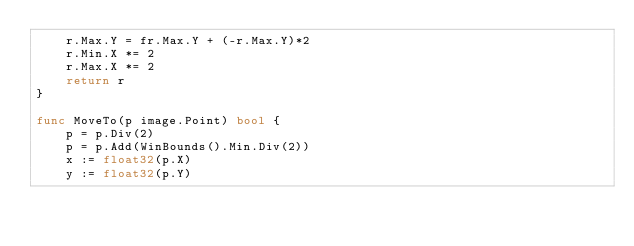<code> <loc_0><loc_0><loc_500><loc_500><_Go_>	r.Max.Y = fr.Max.Y + (-r.Max.Y)*2
	r.Min.X *= 2
	r.Max.X *= 2
	return r
}

func MoveTo(p image.Point) bool {
	p = p.Div(2)
	p = p.Add(WinBounds().Min.Div(2))
	x := float32(p.X)
	y := float32(p.Y)</code> 